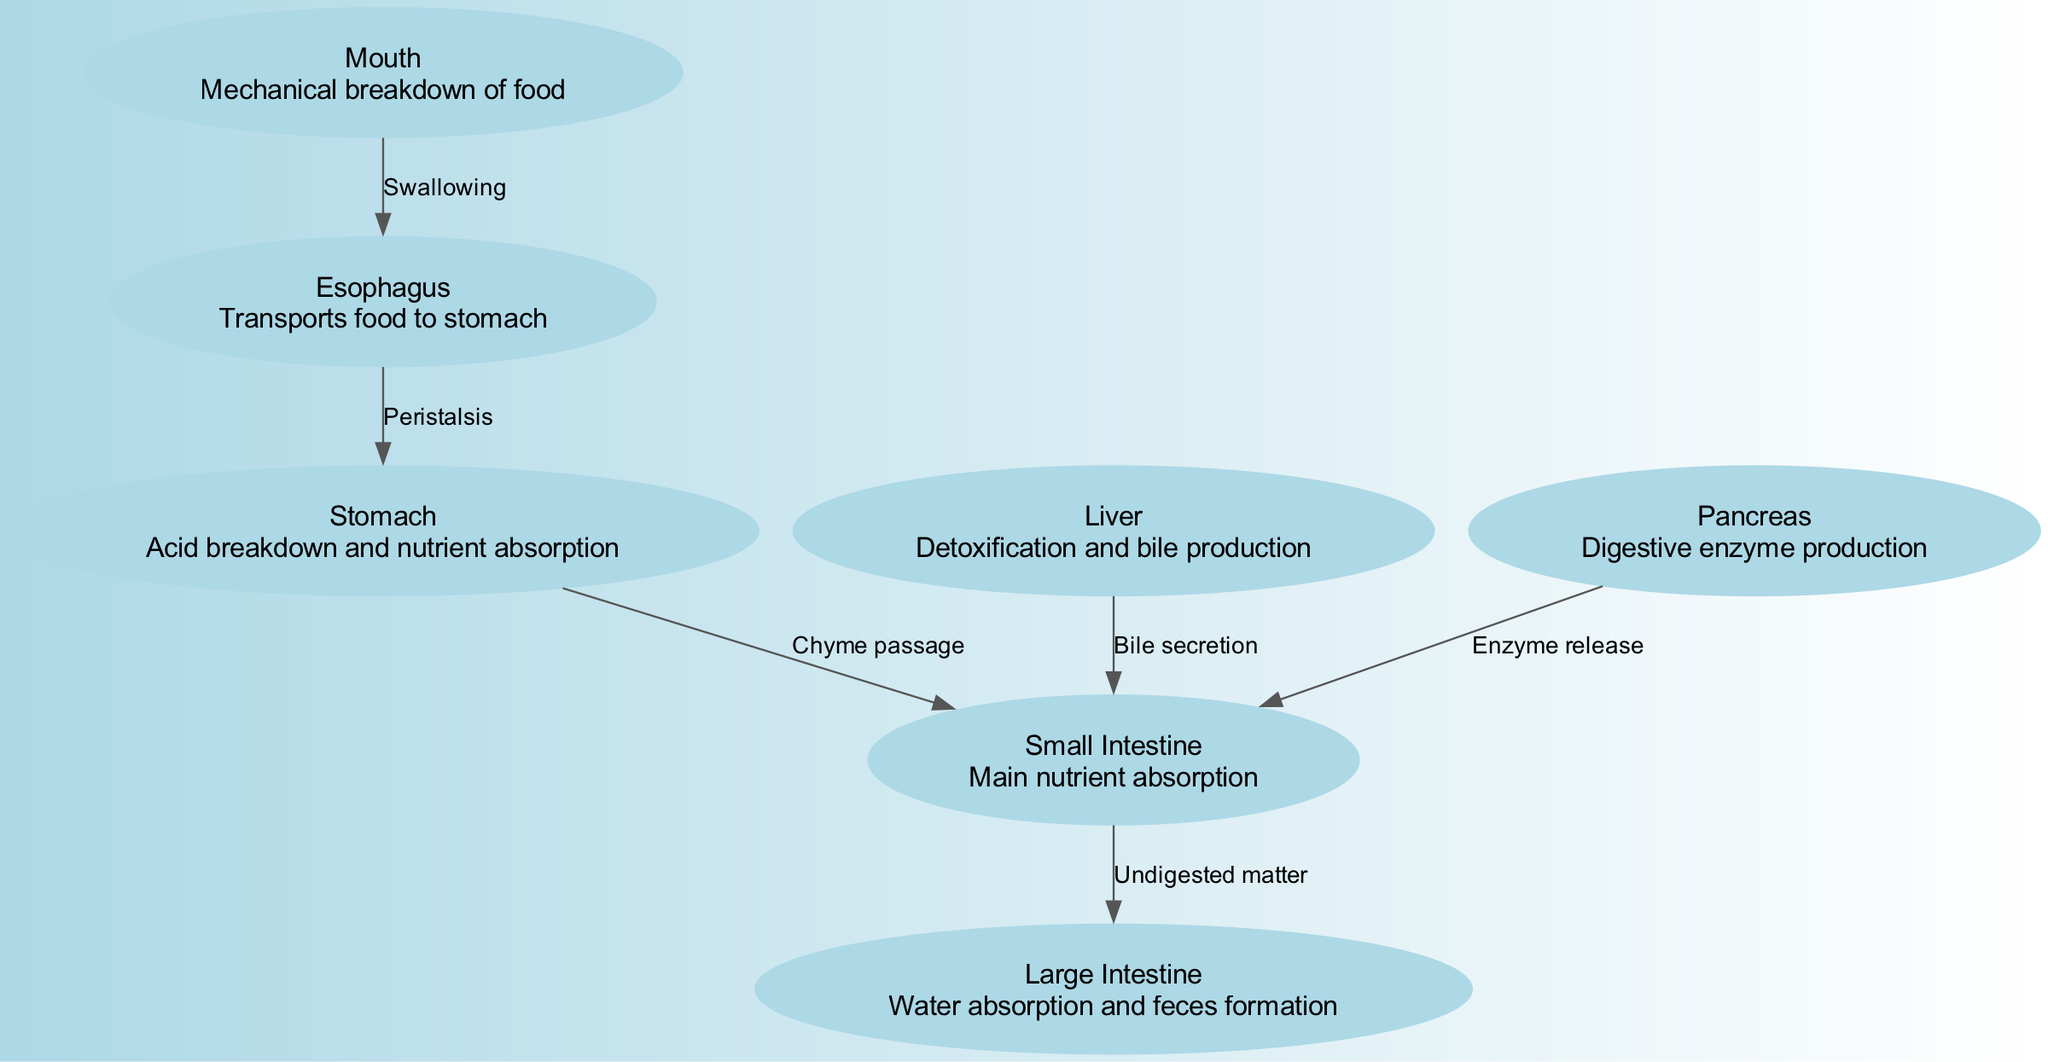What is the first organ in the canine digestive system? The diagram indicates that the first organ in the canine digestive system is the "Mouth."
Answer: Mouth How many main organs are labeled in the diagram? By counting the labeled nodes, there are seven main organs depicted in the diagram: Mouth, Esophagus, Stomach, Small Intestine, Large Intestine, Liver, and Pancreas.
Answer: Seven What process is represented between the mouth and esophagus? The diagram labels the relationship as "Swallowing," indicating the process that occurs between these two organs.
Answer: Swallowing What is the primary function of the liver as shown in the diagram? Based on the diagram, the primary function of the liver is to perform detoxification and bile production.
Answer: Detoxification and bile production What relationship connects the stomach to the small intestine? The diagram specifies that the connection between the stomach and the small intestine is referred to as "Chyme passage."
Answer: Chyme passage What is the major function of the small intestine? According to the diagram, the major function of the small intestine is "Main nutrient absorption."
Answer: Main nutrient absorption How does the pancreas contribute to digestion as per the diagram? The diagram shows that the pancreas plays a role by releasing digestive enzymes into the small intestine, which assist in the digestive process.
Answer: Enzyme release What does the large intestine primarily absorb according to the diagram? The diagram states that the primary function of the large intestine is for water absorption and feces formation.
Answer: Water absorption and feces formation Which two organs supply substances to the small intestine? The diagram indicates that both the liver and pancreas supply substances to the small intestine. The liver secretes bile, while the pancreas releases digestive enzymes.
Answer: Liver and Pancreas 